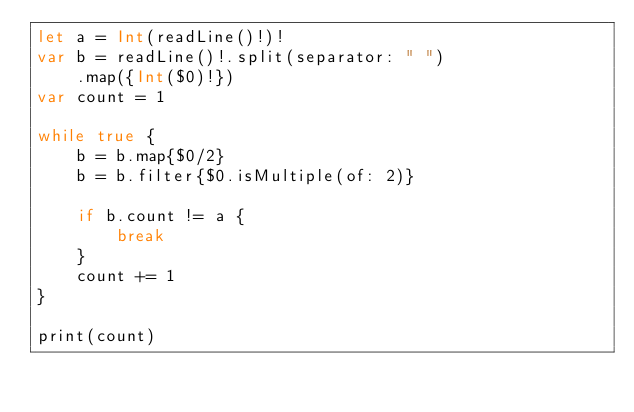<code> <loc_0><loc_0><loc_500><loc_500><_Swift_>let a = Int(readLine()!)!
var b = readLine()!.split(separator: " ")
    .map({Int($0)!})
var count = 1

while true {
    b = b.map{$0/2}
    b = b.filter{$0.isMultiple(of: 2)}

    if b.count != a {
        break
    }
    count += 1
}

print(count)</code> 